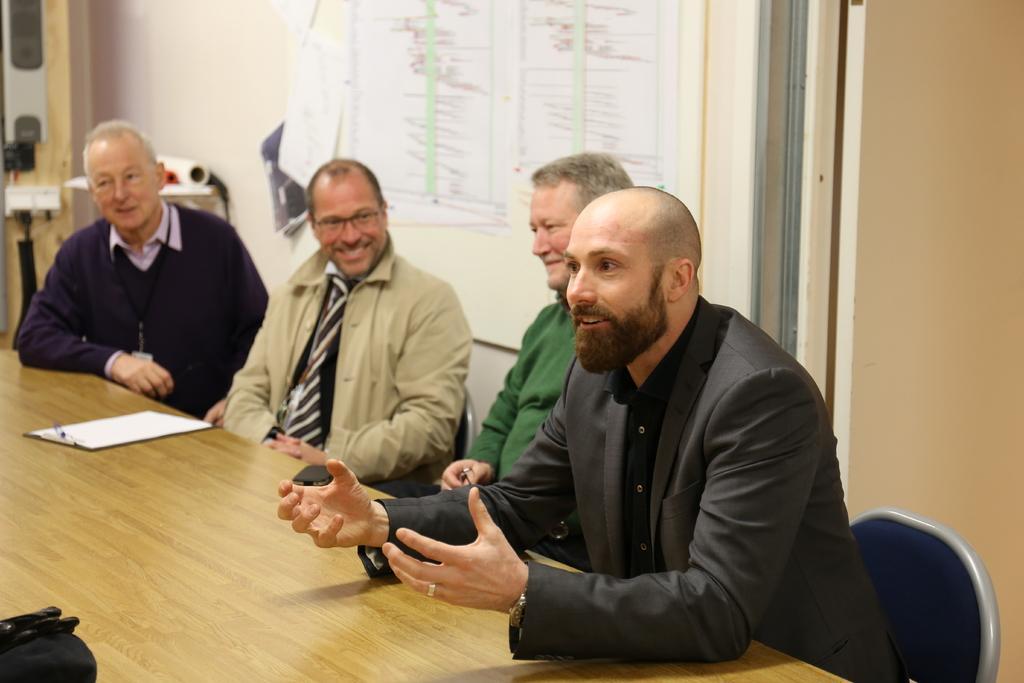Describe this image in one or two sentences. In this image we can see people sitting on the chairs. There is a table on which there is a pad. In the background of the image there is a white color board. There are papers on it. 